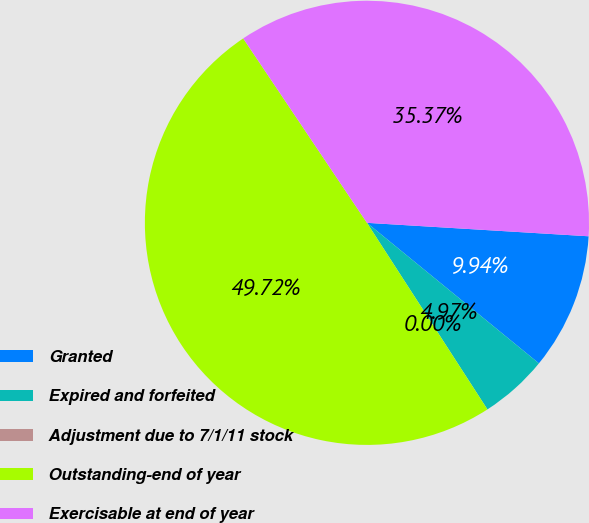<chart> <loc_0><loc_0><loc_500><loc_500><pie_chart><fcel>Granted<fcel>Expired and forfeited<fcel>Adjustment due to 7/1/11 stock<fcel>Outstanding-end of year<fcel>Exercisable at end of year<nl><fcel>9.94%<fcel>4.97%<fcel>0.0%<fcel>49.72%<fcel>35.37%<nl></chart> 